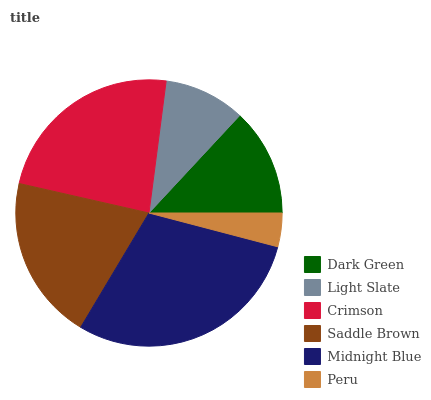Is Peru the minimum?
Answer yes or no. Yes. Is Midnight Blue the maximum?
Answer yes or no. Yes. Is Light Slate the minimum?
Answer yes or no. No. Is Light Slate the maximum?
Answer yes or no. No. Is Dark Green greater than Light Slate?
Answer yes or no. Yes. Is Light Slate less than Dark Green?
Answer yes or no. Yes. Is Light Slate greater than Dark Green?
Answer yes or no. No. Is Dark Green less than Light Slate?
Answer yes or no. No. Is Saddle Brown the high median?
Answer yes or no. Yes. Is Dark Green the low median?
Answer yes or no. Yes. Is Light Slate the high median?
Answer yes or no. No. Is Saddle Brown the low median?
Answer yes or no. No. 